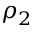<formula> <loc_0><loc_0><loc_500><loc_500>\rho _ { 2 }</formula> 